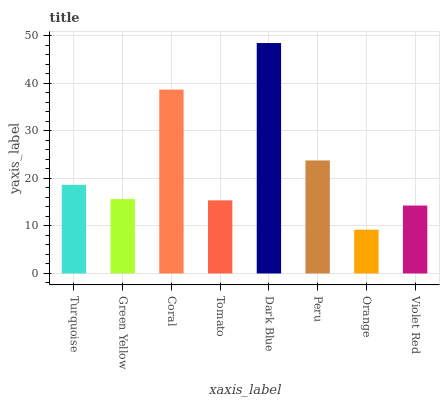Is Orange the minimum?
Answer yes or no. Yes. Is Dark Blue the maximum?
Answer yes or no. Yes. Is Green Yellow the minimum?
Answer yes or no. No. Is Green Yellow the maximum?
Answer yes or no. No. Is Turquoise greater than Green Yellow?
Answer yes or no. Yes. Is Green Yellow less than Turquoise?
Answer yes or no. Yes. Is Green Yellow greater than Turquoise?
Answer yes or no. No. Is Turquoise less than Green Yellow?
Answer yes or no. No. Is Turquoise the high median?
Answer yes or no. Yes. Is Green Yellow the low median?
Answer yes or no. Yes. Is Violet Red the high median?
Answer yes or no. No. Is Turquoise the low median?
Answer yes or no. No. 